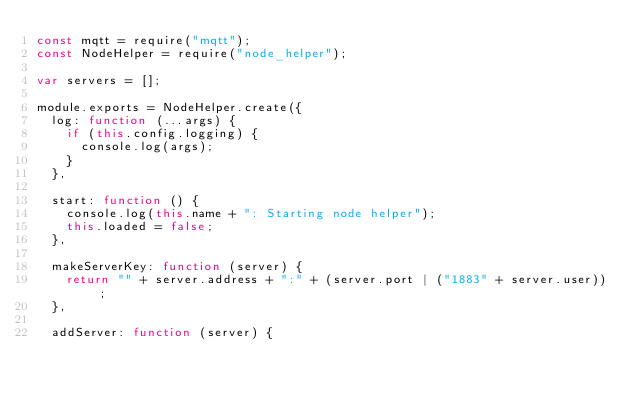Convert code to text. <code><loc_0><loc_0><loc_500><loc_500><_JavaScript_>const mqtt = require("mqtt");
const NodeHelper = require("node_helper");

var servers = [];

module.exports = NodeHelper.create({
  log: function (...args) {
    if (this.config.logging) {
      console.log(args);
    }
  },

  start: function () {
    console.log(this.name + ": Starting node helper");
    this.loaded = false;
  },

  makeServerKey: function (server) {
    return "" + server.address + ":" + (server.port | ("1883" + server.user));
  },

  addServer: function (server) {</code> 